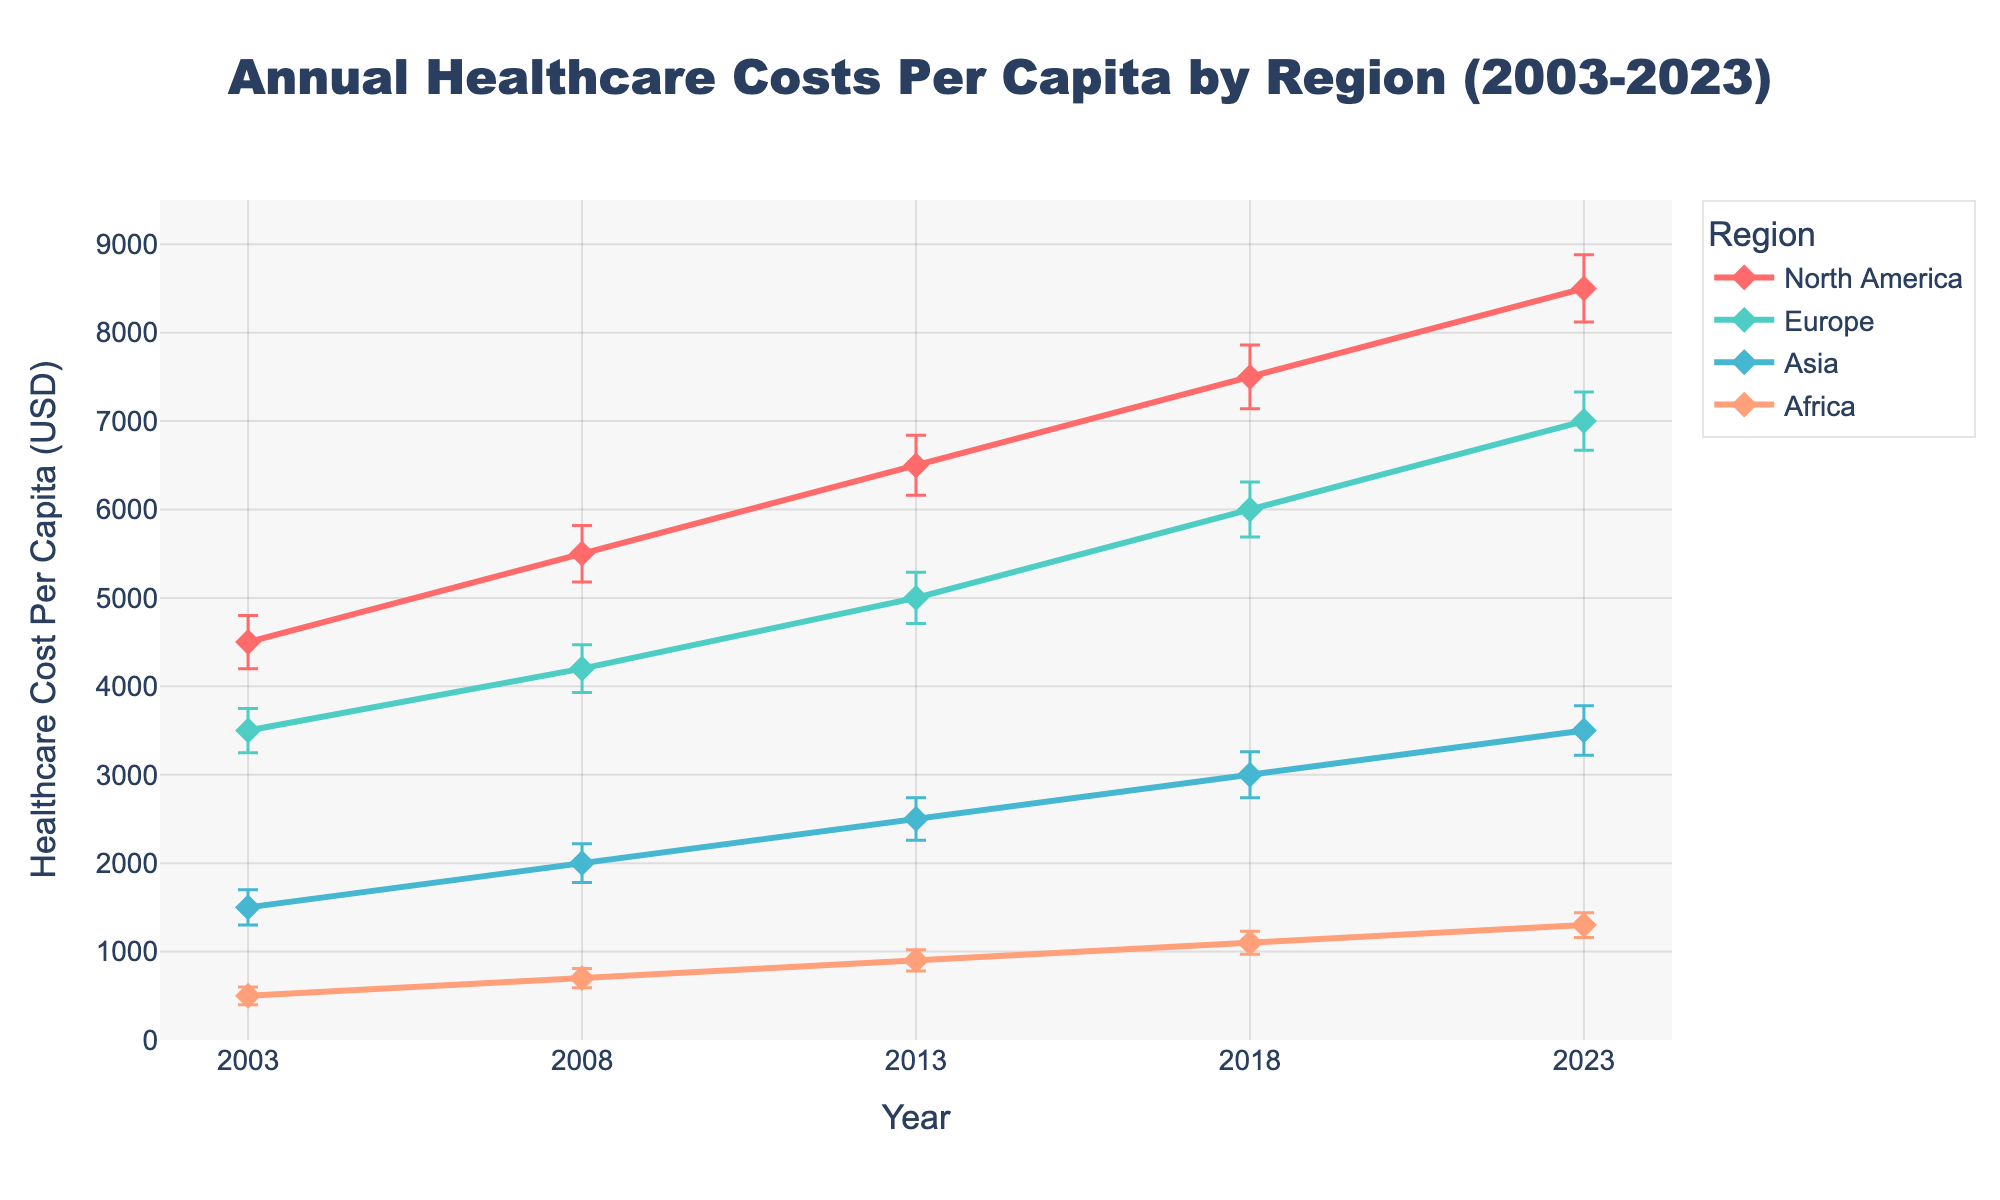What is the title of the figure? The title of the figure is typically located at the top center. In this case, it reads "Annual Healthcare Costs Per Capita by Region (2003-2023)."
Answer: Annual Healthcare Costs Per Capita by Region (2003-2023) Which region had the highest healthcare cost per capita in 2023? From the data points for 2023, the highest healthcare cost per capita is in North America
Answer: North America What's the trend of healthcare costs per capita in Asia over the 20 years? By observing the line plot for Asia, you can notice an upward trend from 1500 in 2003 to 3500 in 2023.
Answer: Upward trend How do the error bars for Europe compare from 2003 to 2023? The error bars for Europe in 2003 and 2023 can be compared by examining their lengths, which represent the standard deviation. The error bars have increased from 250 in 2003 to 330 in 2023, indicating more variability over time.
Answer: Increased variability Which region shows the smallest increase in healthcare costs per capita from 2003 to 2023? By comparing the initial and final healthcare costs, Africa had an increase from 500 in 2003 to 1300 in 2023, which is the smallest increase among the regions.
Answer: Africa In which year did North America see the greatest increase in healthcare costs per capita? To determine the greatest increase, we calculate the differences between years. North America saw the largest increase between 2018 (7500) and 2023 (8500), an increase of 1000.
Answer: 2018-2023 What is the average healthcare cost per capita in Europe over the 20 years? Calculate the average by summing the values for Europe (3500, 4200, 5000, 6000, 7000) and dividing by 5: (3500 + 4200 + 5000 + 6000 + 7000) / 5 = 5140.
Answer: 5140 Compare the healthcare cost per capita in Africa and Asia in 2018. Which one is higher and by how much? The healthcare cost per capita in Africa in 2018 is 1100, and in Asia, it is 3000. Asia's cost is higher by (3000 - 1100) = 1900.
Answer: Asia, by 1900 How have the error bars for North America changed from 2003 to 2023? Comparing error bars for North America from 2003 (300) to 2023 (380), you can see an increase in the standard deviation, indicating greater variability in recent years.
Answer: Increased variability 